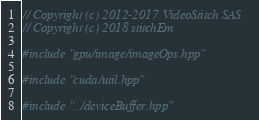<code> <loc_0><loc_0><loc_500><loc_500><_Cuda_>// Copyright (c) 2012-2017 VideoStitch SAS
// Copyright (c) 2018 stitchEm

#include "gpu/image/imageOps.hpp"

#include "cuda/util.hpp"

#include "../deviceBuffer.hpp"</code> 